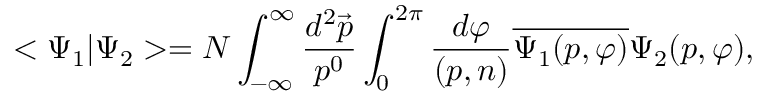Convert formula to latex. <formula><loc_0><loc_0><loc_500><loc_500>< \Psi _ { 1 } | \Psi _ { 2 } > = N \int _ { - \infty } ^ { \infty } \frac { d ^ { 2 } \vec { p } } { p ^ { 0 } } \int _ { 0 } ^ { 2 \pi } \frac { d \varphi } { ( p , n ) } \overline { { { \Psi _ { 1 } ( p , \varphi ) } } } \Psi _ { 2 } ( p , \varphi ) ,</formula> 